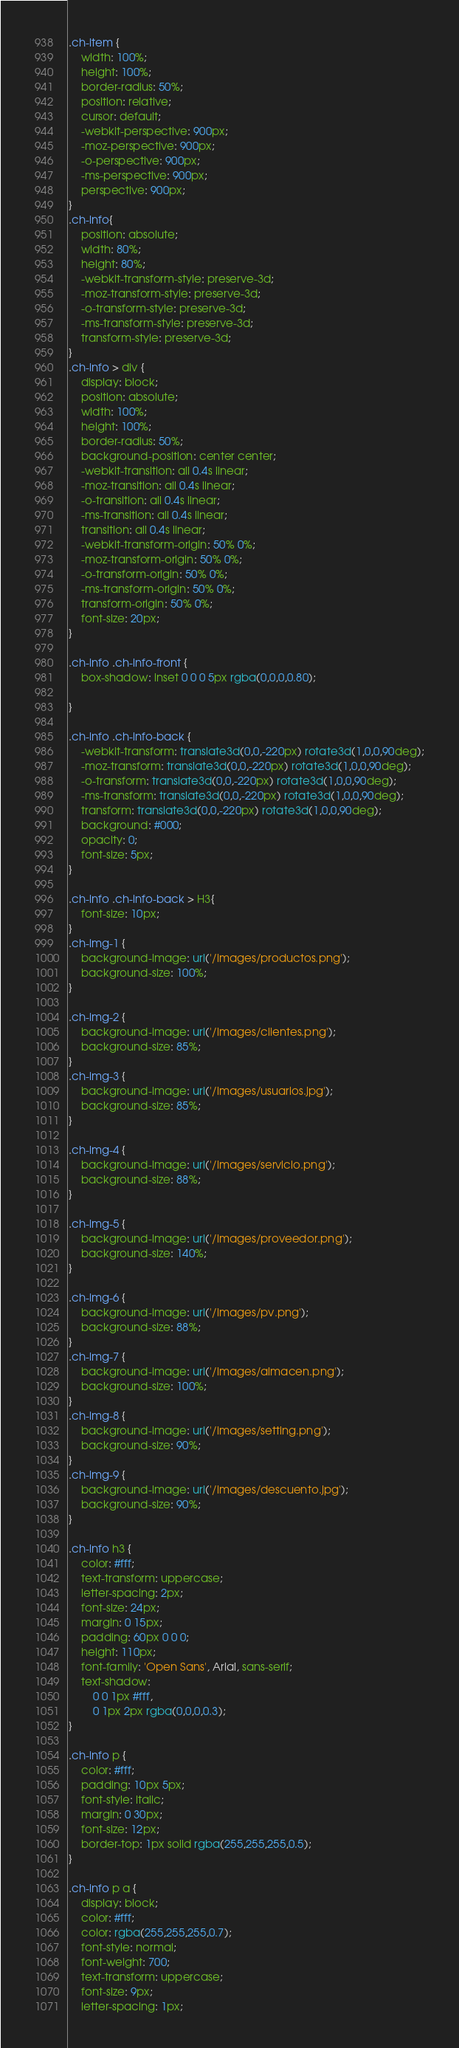Convert code to text. <code><loc_0><loc_0><loc_500><loc_500><_CSS_>.ch-item {
	width: 100%;
	height: 100%;
	border-radius: 50%;
	position: relative;
	cursor: default;
	-webkit-perspective: 900px;
	-moz-perspective: 900px;
	-o-perspective: 900px;
	-ms-perspective: 900px;
	perspective: 900px;
}
.ch-info{
	position: absolute;
	width: 80%;
	height: 80%;
	-webkit-transform-style: preserve-3d;
	-moz-transform-style: preserve-3d;
	-o-transform-style: preserve-3d;
	-ms-transform-style: preserve-3d;
	transform-style: preserve-3d;
}
.ch-info > div {
	display: block;
	position: absolute;
	width: 100%;
	height: 100%;
	border-radius: 50%;
	background-position: center center;
	-webkit-transition: all 0.4s linear;
	-moz-transition: all 0.4s linear;
	-o-transition: all 0.4s linear;
	-ms-transition: all 0.4s linear;
	transition: all 0.4s linear;
	-webkit-transform-origin: 50% 0%;
	-moz-transform-origin: 50% 0%;
	-o-transform-origin: 50% 0%;
	-ms-transform-origin: 50% 0%;
	transform-origin: 50% 0%;
	font-size: 20px;
}

.ch-info .ch-info-front {
	box-shadow: inset 0 0 0 5px rgba(0,0,0,0.80);

}

.ch-info .ch-info-back {
	-webkit-transform: translate3d(0,0,-220px) rotate3d(1,0,0,90deg);
	-moz-transform: translate3d(0,0,-220px) rotate3d(1,0,0,90deg);
	-o-transform: translate3d(0,0,-220px) rotate3d(1,0,0,90deg);
	-ms-transform: translate3d(0,0,-220px) rotate3d(1,0,0,90deg);
	transform: translate3d(0,0,-220px) rotate3d(1,0,0,90deg);
	background: #000;
	opacity: 0;
	font-size: 5px;
}

.ch-info .ch-info-back > H3{
	font-size: 10px;
}
.ch-img-1 { 
	background-image: url('/images/productos.png');
	background-size: 100%;
}

.ch-img-2 { 
	background-image: url('/images/clientes.png');
	background-size: 85%;
}
.ch-img-3 { 
	background-image: url('/images/usuarios.jpg');
	background-size: 85%;
}

.ch-img-4 { 
	background-image: url('/images/servicio.png');
	background-size: 88%;
}

.ch-img-5 { 
	background-image: url('/images/proveedor.png');
	background-size: 140%;
}

.ch-img-6 { 
	background-image: url('/images/pv.png');
	background-size: 88%;
}
.ch-img-7 { 
	background-image: url('/images/almacen.png');
	background-size: 100%;
}
.ch-img-8 { 
	background-image: url('/images/setting.png');
	background-size: 90%;
}
.ch-img-9 { 
	background-image: url('/images/descuento.jpg');
	background-size: 90%;
}

.ch-info h3 {
	color: #fff;
	text-transform: uppercase;
	letter-spacing: 2px;
	font-size: 24px;
	margin: 0 15px;
	padding: 60px 0 0 0;
	height: 110px;
	font-family: 'Open Sans', Arial, sans-serif;
	text-shadow: 
		0 0 1px #fff, 
		0 1px 2px rgba(0,0,0,0.3);
}

.ch-info p {
	color: #fff;
	padding: 10px 5px;
	font-style: italic;
	margin: 0 30px;
	font-size: 12px;
	border-top: 1px solid rgba(255,255,255,0.5);
}

.ch-info p a {
	display: block;
	color: #fff;
	color: rgba(255,255,255,0.7);
	font-style: normal;
	font-weight: 700;
	text-transform: uppercase;
	font-size: 9px;
	letter-spacing: 1px;</code> 